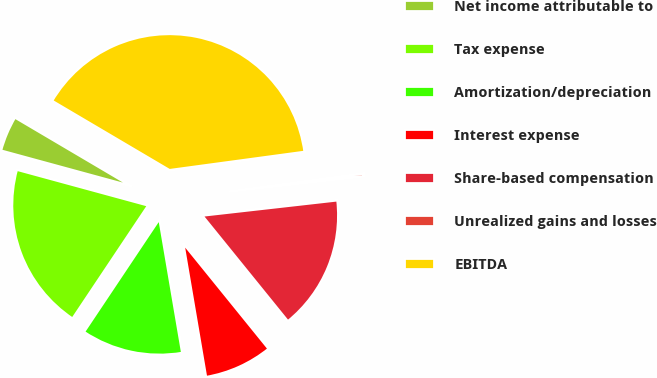Convert chart to OTSL. <chart><loc_0><loc_0><loc_500><loc_500><pie_chart><fcel>Net income attributable to<fcel>Tax expense<fcel>Amortization/depreciation<fcel>Interest expense<fcel>Share-based compensation<fcel>Unrealized gains and losses<fcel>EBITDA<nl><fcel>4.25%<fcel>19.86%<fcel>12.06%<fcel>8.15%<fcel>15.96%<fcel>0.35%<fcel>39.38%<nl></chart> 